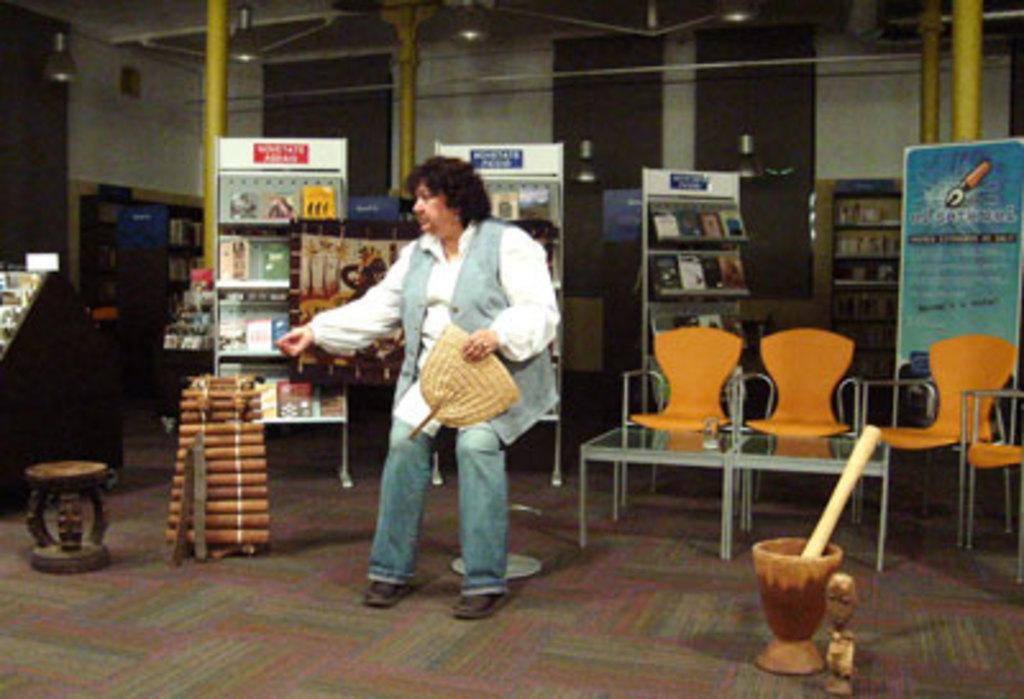What is present in the image? There is a person, chairs, books, and shelves in the image. Can you describe the person in the image? The provided facts do not give any details about the person's appearance or actions. What are the books placed on? The books are placed on shelves in the image. How many chairs are visible in the image? The provided facts do not specify the number of chairs. How far away is the servant from the person in the image? There is no servant present in the image. What is the weight of the books in the image? The provided facts do not give any information about the weight of the books. 